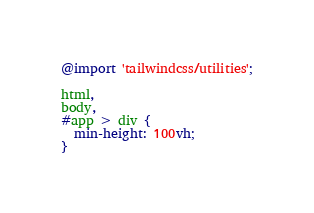Convert code to text. <code><loc_0><loc_0><loc_500><loc_500><_CSS_>@import 'tailwindcss/utilities';

html,
body,
#app > div {
  min-height: 100vh;
}
</code> 